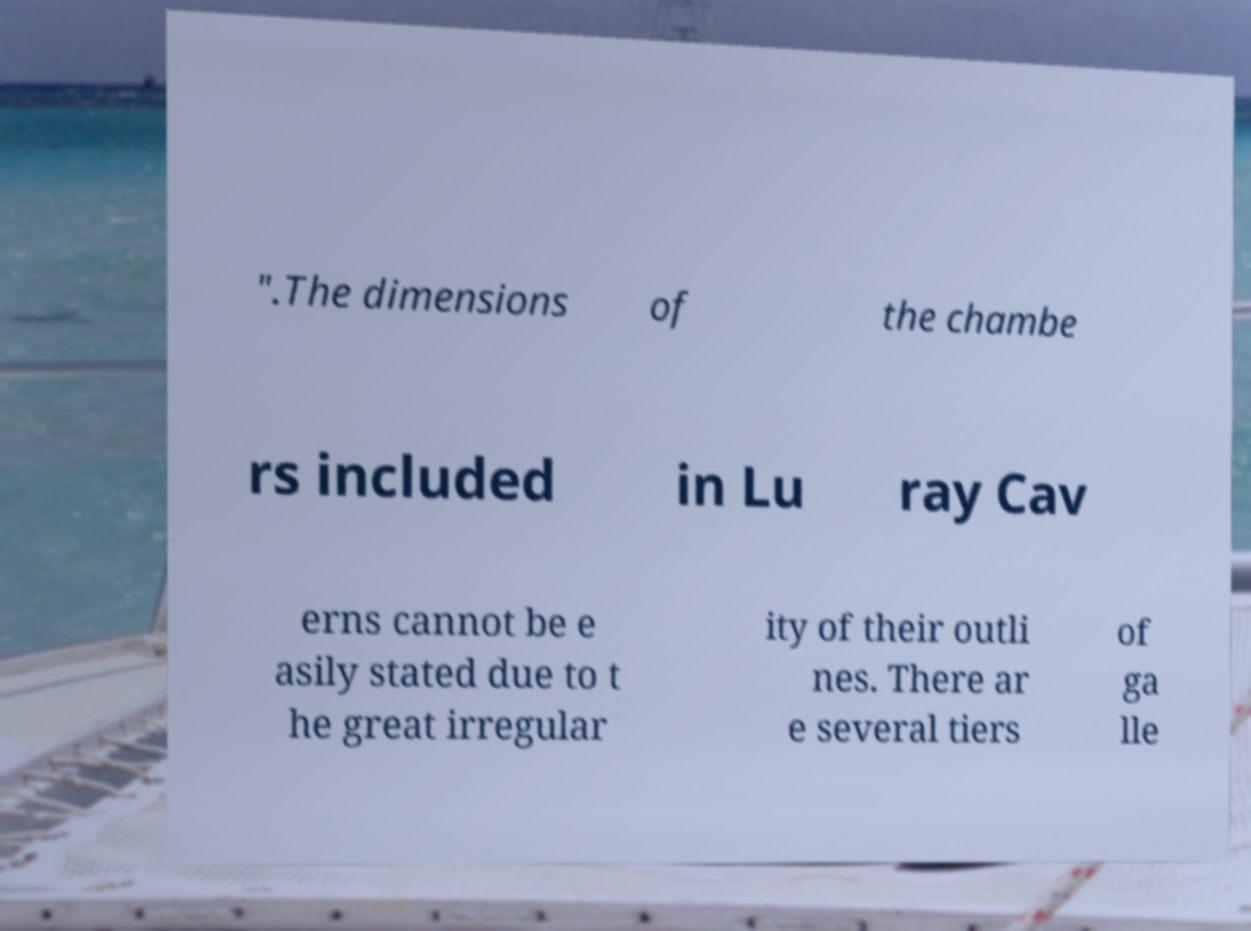Can you read and provide the text displayed in the image?This photo seems to have some interesting text. Can you extract and type it out for me? ".The dimensions of the chambe rs included in Lu ray Cav erns cannot be e asily stated due to t he great irregular ity of their outli nes. There ar e several tiers of ga lle 